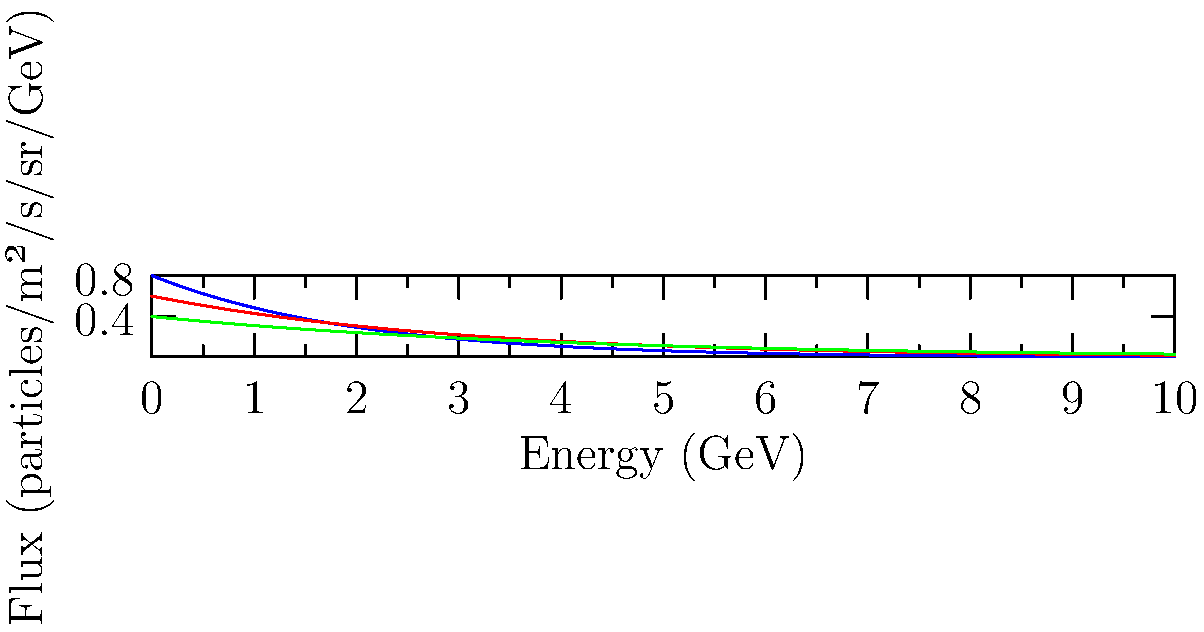Based on the energy spectra shown in the graph, which type of cosmic radiation exhibits the steepest decline in flux as energy increases? To determine which type of cosmic radiation shows the steepest decline in flux with increasing energy, we need to analyze the slopes of the curves:

1. The steepness of the curve represents how quickly the flux decreases as energy increases.
2. A steeper curve indicates a more rapid decrease in flux.
3. The curves in the graph are exponential functions of the form $f(x) = Ae^{-x/b}$, where $A$ is the initial flux and $b$ is the decay constant.
4. The smaller the value of $b$, the steeper the curve.
5. Comparing the curves:
   - Gamma rays (blue): steepest decline
   - Cosmic rays (red): intermediate decline
   - Solar energetic particles (green): shallowest decline
6. The gamma ray curve (blue) shows the most rapid decrease in flux as energy increases.

Therefore, gamma rays exhibit the steepest decline in flux as energy increases.
Answer: Gamma rays 